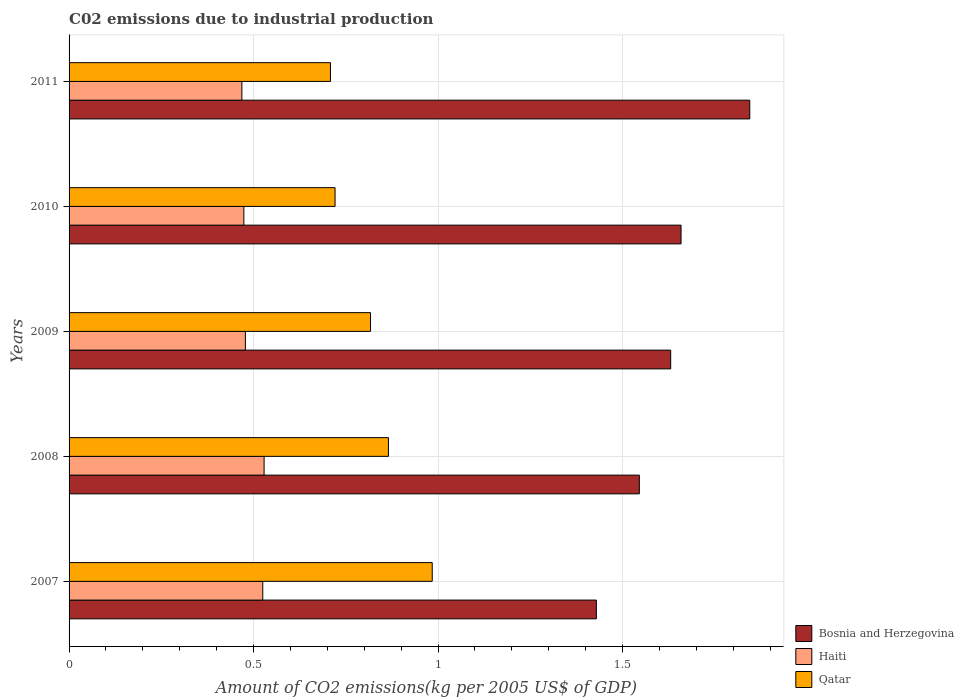How many bars are there on the 1st tick from the top?
Provide a short and direct response. 3. What is the label of the 4th group of bars from the top?
Your answer should be compact. 2008. What is the amount of CO2 emitted due to industrial production in Bosnia and Herzegovina in 2008?
Ensure brevity in your answer.  1.55. Across all years, what is the maximum amount of CO2 emitted due to industrial production in Qatar?
Give a very brief answer. 0.98. Across all years, what is the minimum amount of CO2 emitted due to industrial production in Qatar?
Give a very brief answer. 0.71. What is the total amount of CO2 emitted due to industrial production in Haiti in the graph?
Your answer should be compact. 2.47. What is the difference between the amount of CO2 emitted due to industrial production in Qatar in 2009 and that in 2011?
Make the answer very short. 0.11. What is the difference between the amount of CO2 emitted due to industrial production in Bosnia and Herzegovina in 2010 and the amount of CO2 emitted due to industrial production in Haiti in 2011?
Your response must be concise. 1.19. What is the average amount of CO2 emitted due to industrial production in Haiti per year?
Ensure brevity in your answer.  0.49. In the year 2007, what is the difference between the amount of CO2 emitted due to industrial production in Qatar and amount of CO2 emitted due to industrial production in Haiti?
Your answer should be compact. 0.46. In how many years, is the amount of CO2 emitted due to industrial production in Bosnia and Herzegovina greater than 1.6 kg?
Ensure brevity in your answer.  3. What is the ratio of the amount of CO2 emitted due to industrial production in Haiti in 2008 to that in 2010?
Make the answer very short. 1.12. Is the difference between the amount of CO2 emitted due to industrial production in Qatar in 2008 and 2011 greater than the difference between the amount of CO2 emitted due to industrial production in Haiti in 2008 and 2011?
Your response must be concise. Yes. What is the difference between the highest and the second highest amount of CO2 emitted due to industrial production in Haiti?
Offer a terse response. 0. What is the difference between the highest and the lowest amount of CO2 emitted due to industrial production in Haiti?
Provide a succinct answer. 0.06. Is the sum of the amount of CO2 emitted due to industrial production in Bosnia and Herzegovina in 2009 and 2011 greater than the maximum amount of CO2 emitted due to industrial production in Qatar across all years?
Make the answer very short. Yes. What does the 3rd bar from the top in 2010 represents?
Offer a terse response. Bosnia and Herzegovina. What does the 1st bar from the bottom in 2010 represents?
Your answer should be very brief. Bosnia and Herzegovina. Is it the case that in every year, the sum of the amount of CO2 emitted due to industrial production in Haiti and amount of CO2 emitted due to industrial production in Bosnia and Herzegovina is greater than the amount of CO2 emitted due to industrial production in Qatar?
Offer a terse response. Yes. How many years are there in the graph?
Your response must be concise. 5. Are the values on the major ticks of X-axis written in scientific E-notation?
Your response must be concise. No. Does the graph contain any zero values?
Make the answer very short. No. Does the graph contain grids?
Your answer should be compact. Yes. How many legend labels are there?
Offer a terse response. 3. How are the legend labels stacked?
Provide a succinct answer. Vertical. What is the title of the graph?
Offer a terse response. C02 emissions due to industrial production. Does "Caribbean small states" appear as one of the legend labels in the graph?
Make the answer very short. No. What is the label or title of the X-axis?
Keep it short and to the point. Amount of CO2 emissions(kg per 2005 US$ of GDP). What is the label or title of the Y-axis?
Provide a succinct answer. Years. What is the Amount of CO2 emissions(kg per 2005 US$ of GDP) in Bosnia and Herzegovina in 2007?
Keep it short and to the point. 1.43. What is the Amount of CO2 emissions(kg per 2005 US$ of GDP) of Haiti in 2007?
Provide a succinct answer. 0.52. What is the Amount of CO2 emissions(kg per 2005 US$ of GDP) of Qatar in 2007?
Offer a terse response. 0.98. What is the Amount of CO2 emissions(kg per 2005 US$ of GDP) of Bosnia and Herzegovina in 2008?
Ensure brevity in your answer.  1.55. What is the Amount of CO2 emissions(kg per 2005 US$ of GDP) in Haiti in 2008?
Your answer should be very brief. 0.53. What is the Amount of CO2 emissions(kg per 2005 US$ of GDP) in Qatar in 2008?
Keep it short and to the point. 0.87. What is the Amount of CO2 emissions(kg per 2005 US$ of GDP) of Bosnia and Herzegovina in 2009?
Make the answer very short. 1.63. What is the Amount of CO2 emissions(kg per 2005 US$ of GDP) in Haiti in 2009?
Provide a succinct answer. 0.48. What is the Amount of CO2 emissions(kg per 2005 US$ of GDP) in Qatar in 2009?
Make the answer very short. 0.82. What is the Amount of CO2 emissions(kg per 2005 US$ of GDP) in Bosnia and Herzegovina in 2010?
Keep it short and to the point. 1.66. What is the Amount of CO2 emissions(kg per 2005 US$ of GDP) of Haiti in 2010?
Offer a very short reply. 0.47. What is the Amount of CO2 emissions(kg per 2005 US$ of GDP) of Qatar in 2010?
Keep it short and to the point. 0.72. What is the Amount of CO2 emissions(kg per 2005 US$ of GDP) in Bosnia and Herzegovina in 2011?
Your answer should be very brief. 1.84. What is the Amount of CO2 emissions(kg per 2005 US$ of GDP) in Haiti in 2011?
Make the answer very short. 0.47. What is the Amount of CO2 emissions(kg per 2005 US$ of GDP) of Qatar in 2011?
Ensure brevity in your answer.  0.71. Across all years, what is the maximum Amount of CO2 emissions(kg per 2005 US$ of GDP) in Bosnia and Herzegovina?
Your response must be concise. 1.84. Across all years, what is the maximum Amount of CO2 emissions(kg per 2005 US$ of GDP) of Haiti?
Provide a short and direct response. 0.53. Across all years, what is the maximum Amount of CO2 emissions(kg per 2005 US$ of GDP) in Qatar?
Your answer should be very brief. 0.98. Across all years, what is the minimum Amount of CO2 emissions(kg per 2005 US$ of GDP) of Bosnia and Herzegovina?
Provide a short and direct response. 1.43. Across all years, what is the minimum Amount of CO2 emissions(kg per 2005 US$ of GDP) of Haiti?
Make the answer very short. 0.47. Across all years, what is the minimum Amount of CO2 emissions(kg per 2005 US$ of GDP) in Qatar?
Your answer should be compact. 0.71. What is the total Amount of CO2 emissions(kg per 2005 US$ of GDP) in Bosnia and Herzegovina in the graph?
Ensure brevity in your answer.  8.11. What is the total Amount of CO2 emissions(kg per 2005 US$ of GDP) in Haiti in the graph?
Offer a terse response. 2.47. What is the total Amount of CO2 emissions(kg per 2005 US$ of GDP) in Qatar in the graph?
Make the answer very short. 4.1. What is the difference between the Amount of CO2 emissions(kg per 2005 US$ of GDP) in Bosnia and Herzegovina in 2007 and that in 2008?
Offer a terse response. -0.12. What is the difference between the Amount of CO2 emissions(kg per 2005 US$ of GDP) in Haiti in 2007 and that in 2008?
Provide a succinct answer. -0. What is the difference between the Amount of CO2 emissions(kg per 2005 US$ of GDP) of Qatar in 2007 and that in 2008?
Make the answer very short. 0.12. What is the difference between the Amount of CO2 emissions(kg per 2005 US$ of GDP) in Bosnia and Herzegovina in 2007 and that in 2009?
Provide a short and direct response. -0.2. What is the difference between the Amount of CO2 emissions(kg per 2005 US$ of GDP) of Haiti in 2007 and that in 2009?
Keep it short and to the point. 0.05. What is the difference between the Amount of CO2 emissions(kg per 2005 US$ of GDP) of Qatar in 2007 and that in 2009?
Offer a very short reply. 0.17. What is the difference between the Amount of CO2 emissions(kg per 2005 US$ of GDP) of Bosnia and Herzegovina in 2007 and that in 2010?
Offer a very short reply. -0.23. What is the difference between the Amount of CO2 emissions(kg per 2005 US$ of GDP) in Haiti in 2007 and that in 2010?
Provide a short and direct response. 0.05. What is the difference between the Amount of CO2 emissions(kg per 2005 US$ of GDP) in Qatar in 2007 and that in 2010?
Make the answer very short. 0.26. What is the difference between the Amount of CO2 emissions(kg per 2005 US$ of GDP) of Bosnia and Herzegovina in 2007 and that in 2011?
Provide a succinct answer. -0.42. What is the difference between the Amount of CO2 emissions(kg per 2005 US$ of GDP) in Haiti in 2007 and that in 2011?
Give a very brief answer. 0.06. What is the difference between the Amount of CO2 emissions(kg per 2005 US$ of GDP) of Qatar in 2007 and that in 2011?
Offer a terse response. 0.28. What is the difference between the Amount of CO2 emissions(kg per 2005 US$ of GDP) in Bosnia and Herzegovina in 2008 and that in 2009?
Offer a very short reply. -0.09. What is the difference between the Amount of CO2 emissions(kg per 2005 US$ of GDP) in Haiti in 2008 and that in 2009?
Your answer should be very brief. 0.05. What is the difference between the Amount of CO2 emissions(kg per 2005 US$ of GDP) in Qatar in 2008 and that in 2009?
Offer a terse response. 0.05. What is the difference between the Amount of CO2 emissions(kg per 2005 US$ of GDP) in Bosnia and Herzegovina in 2008 and that in 2010?
Offer a very short reply. -0.11. What is the difference between the Amount of CO2 emissions(kg per 2005 US$ of GDP) of Haiti in 2008 and that in 2010?
Offer a very short reply. 0.05. What is the difference between the Amount of CO2 emissions(kg per 2005 US$ of GDP) of Qatar in 2008 and that in 2010?
Provide a succinct answer. 0.14. What is the difference between the Amount of CO2 emissions(kg per 2005 US$ of GDP) of Bosnia and Herzegovina in 2008 and that in 2011?
Make the answer very short. -0.3. What is the difference between the Amount of CO2 emissions(kg per 2005 US$ of GDP) of Haiti in 2008 and that in 2011?
Give a very brief answer. 0.06. What is the difference between the Amount of CO2 emissions(kg per 2005 US$ of GDP) in Qatar in 2008 and that in 2011?
Provide a succinct answer. 0.16. What is the difference between the Amount of CO2 emissions(kg per 2005 US$ of GDP) of Bosnia and Herzegovina in 2009 and that in 2010?
Keep it short and to the point. -0.03. What is the difference between the Amount of CO2 emissions(kg per 2005 US$ of GDP) of Haiti in 2009 and that in 2010?
Your answer should be very brief. 0. What is the difference between the Amount of CO2 emissions(kg per 2005 US$ of GDP) in Qatar in 2009 and that in 2010?
Keep it short and to the point. 0.1. What is the difference between the Amount of CO2 emissions(kg per 2005 US$ of GDP) of Bosnia and Herzegovina in 2009 and that in 2011?
Make the answer very short. -0.21. What is the difference between the Amount of CO2 emissions(kg per 2005 US$ of GDP) in Haiti in 2009 and that in 2011?
Keep it short and to the point. 0.01. What is the difference between the Amount of CO2 emissions(kg per 2005 US$ of GDP) of Qatar in 2009 and that in 2011?
Make the answer very short. 0.11. What is the difference between the Amount of CO2 emissions(kg per 2005 US$ of GDP) in Bosnia and Herzegovina in 2010 and that in 2011?
Ensure brevity in your answer.  -0.19. What is the difference between the Amount of CO2 emissions(kg per 2005 US$ of GDP) of Haiti in 2010 and that in 2011?
Provide a short and direct response. 0.01. What is the difference between the Amount of CO2 emissions(kg per 2005 US$ of GDP) in Qatar in 2010 and that in 2011?
Offer a terse response. 0.01. What is the difference between the Amount of CO2 emissions(kg per 2005 US$ of GDP) of Bosnia and Herzegovina in 2007 and the Amount of CO2 emissions(kg per 2005 US$ of GDP) of Haiti in 2008?
Provide a succinct answer. 0.9. What is the difference between the Amount of CO2 emissions(kg per 2005 US$ of GDP) of Bosnia and Herzegovina in 2007 and the Amount of CO2 emissions(kg per 2005 US$ of GDP) of Qatar in 2008?
Your answer should be very brief. 0.56. What is the difference between the Amount of CO2 emissions(kg per 2005 US$ of GDP) in Haiti in 2007 and the Amount of CO2 emissions(kg per 2005 US$ of GDP) in Qatar in 2008?
Provide a succinct answer. -0.34. What is the difference between the Amount of CO2 emissions(kg per 2005 US$ of GDP) of Bosnia and Herzegovina in 2007 and the Amount of CO2 emissions(kg per 2005 US$ of GDP) of Haiti in 2009?
Make the answer very short. 0.95. What is the difference between the Amount of CO2 emissions(kg per 2005 US$ of GDP) of Bosnia and Herzegovina in 2007 and the Amount of CO2 emissions(kg per 2005 US$ of GDP) of Qatar in 2009?
Ensure brevity in your answer.  0.61. What is the difference between the Amount of CO2 emissions(kg per 2005 US$ of GDP) in Haiti in 2007 and the Amount of CO2 emissions(kg per 2005 US$ of GDP) in Qatar in 2009?
Keep it short and to the point. -0.29. What is the difference between the Amount of CO2 emissions(kg per 2005 US$ of GDP) in Bosnia and Herzegovina in 2007 and the Amount of CO2 emissions(kg per 2005 US$ of GDP) in Haiti in 2010?
Your response must be concise. 0.96. What is the difference between the Amount of CO2 emissions(kg per 2005 US$ of GDP) of Bosnia and Herzegovina in 2007 and the Amount of CO2 emissions(kg per 2005 US$ of GDP) of Qatar in 2010?
Give a very brief answer. 0.71. What is the difference between the Amount of CO2 emissions(kg per 2005 US$ of GDP) of Haiti in 2007 and the Amount of CO2 emissions(kg per 2005 US$ of GDP) of Qatar in 2010?
Provide a short and direct response. -0.2. What is the difference between the Amount of CO2 emissions(kg per 2005 US$ of GDP) of Bosnia and Herzegovina in 2007 and the Amount of CO2 emissions(kg per 2005 US$ of GDP) of Haiti in 2011?
Provide a succinct answer. 0.96. What is the difference between the Amount of CO2 emissions(kg per 2005 US$ of GDP) of Bosnia and Herzegovina in 2007 and the Amount of CO2 emissions(kg per 2005 US$ of GDP) of Qatar in 2011?
Keep it short and to the point. 0.72. What is the difference between the Amount of CO2 emissions(kg per 2005 US$ of GDP) in Haiti in 2007 and the Amount of CO2 emissions(kg per 2005 US$ of GDP) in Qatar in 2011?
Make the answer very short. -0.18. What is the difference between the Amount of CO2 emissions(kg per 2005 US$ of GDP) of Bosnia and Herzegovina in 2008 and the Amount of CO2 emissions(kg per 2005 US$ of GDP) of Haiti in 2009?
Offer a terse response. 1.07. What is the difference between the Amount of CO2 emissions(kg per 2005 US$ of GDP) of Bosnia and Herzegovina in 2008 and the Amount of CO2 emissions(kg per 2005 US$ of GDP) of Qatar in 2009?
Make the answer very short. 0.73. What is the difference between the Amount of CO2 emissions(kg per 2005 US$ of GDP) in Haiti in 2008 and the Amount of CO2 emissions(kg per 2005 US$ of GDP) in Qatar in 2009?
Ensure brevity in your answer.  -0.29. What is the difference between the Amount of CO2 emissions(kg per 2005 US$ of GDP) of Bosnia and Herzegovina in 2008 and the Amount of CO2 emissions(kg per 2005 US$ of GDP) of Haiti in 2010?
Your answer should be very brief. 1.07. What is the difference between the Amount of CO2 emissions(kg per 2005 US$ of GDP) in Bosnia and Herzegovina in 2008 and the Amount of CO2 emissions(kg per 2005 US$ of GDP) in Qatar in 2010?
Provide a short and direct response. 0.82. What is the difference between the Amount of CO2 emissions(kg per 2005 US$ of GDP) in Haiti in 2008 and the Amount of CO2 emissions(kg per 2005 US$ of GDP) in Qatar in 2010?
Provide a succinct answer. -0.19. What is the difference between the Amount of CO2 emissions(kg per 2005 US$ of GDP) in Bosnia and Herzegovina in 2008 and the Amount of CO2 emissions(kg per 2005 US$ of GDP) in Haiti in 2011?
Your answer should be compact. 1.08. What is the difference between the Amount of CO2 emissions(kg per 2005 US$ of GDP) of Bosnia and Herzegovina in 2008 and the Amount of CO2 emissions(kg per 2005 US$ of GDP) of Qatar in 2011?
Give a very brief answer. 0.84. What is the difference between the Amount of CO2 emissions(kg per 2005 US$ of GDP) in Haiti in 2008 and the Amount of CO2 emissions(kg per 2005 US$ of GDP) in Qatar in 2011?
Offer a terse response. -0.18. What is the difference between the Amount of CO2 emissions(kg per 2005 US$ of GDP) of Bosnia and Herzegovina in 2009 and the Amount of CO2 emissions(kg per 2005 US$ of GDP) of Haiti in 2010?
Offer a terse response. 1.16. What is the difference between the Amount of CO2 emissions(kg per 2005 US$ of GDP) of Bosnia and Herzegovina in 2009 and the Amount of CO2 emissions(kg per 2005 US$ of GDP) of Qatar in 2010?
Your response must be concise. 0.91. What is the difference between the Amount of CO2 emissions(kg per 2005 US$ of GDP) of Haiti in 2009 and the Amount of CO2 emissions(kg per 2005 US$ of GDP) of Qatar in 2010?
Provide a short and direct response. -0.24. What is the difference between the Amount of CO2 emissions(kg per 2005 US$ of GDP) in Bosnia and Herzegovina in 2009 and the Amount of CO2 emissions(kg per 2005 US$ of GDP) in Haiti in 2011?
Make the answer very short. 1.16. What is the difference between the Amount of CO2 emissions(kg per 2005 US$ of GDP) in Bosnia and Herzegovina in 2009 and the Amount of CO2 emissions(kg per 2005 US$ of GDP) in Qatar in 2011?
Provide a short and direct response. 0.92. What is the difference between the Amount of CO2 emissions(kg per 2005 US$ of GDP) in Haiti in 2009 and the Amount of CO2 emissions(kg per 2005 US$ of GDP) in Qatar in 2011?
Offer a terse response. -0.23. What is the difference between the Amount of CO2 emissions(kg per 2005 US$ of GDP) in Bosnia and Herzegovina in 2010 and the Amount of CO2 emissions(kg per 2005 US$ of GDP) in Haiti in 2011?
Your response must be concise. 1.19. What is the difference between the Amount of CO2 emissions(kg per 2005 US$ of GDP) of Bosnia and Herzegovina in 2010 and the Amount of CO2 emissions(kg per 2005 US$ of GDP) of Qatar in 2011?
Offer a terse response. 0.95. What is the difference between the Amount of CO2 emissions(kg per 2005 US$ of GDP) in Haiti in 2010 and the Amount of CO2 emissions(kg per 2005 US$ of GDP) in Qatar in 2011?
Your answer should be very brief. -0.23. What is the average Amount of CO2 emissions(kg per 2005 US$ of GDP) of Bosnia and Herzegovina per year?
Make the answer very short. 1.62. What is the average Amount of CO2 emissions(kg per 2005 US$ of GDP) in Haiti per year?
Give a very brief answer. 0.49. What is the average Amount of CO2 emissions(kg per 2005 US$ of GDP) of Qatar per year?
Your answer should be compact. 0.82. In the year 2007, what is the difference between the Amount of CO2 emissions(kg per 2005 US$ of GDP) in Bosnia and Herzegovina and Amount of CO2 emissions(kg per 2005 US$ of GDP) in Haiti?
Give a very brief answer. 0.9. In the year 2007, what is the difference between the Amount of CO2 emissions(kg per 2005 US$ of GDP) in Bosnia and Herzegovina and Amount of CO2 emissions(kg per 2005 US$ of GDP) in Qatar?
Your response must be concise. 0.44. In the year 2007, what is the difference between the Amount of CO2 emissions(kg per 2005 US$ of GDP) of Haiti and Amount of CO2 emissions(kg per 2005 US$ of GDP) of Qatar?
Provide a short and direct response. -0.46. In the year 2008, what is the difference between the Amount of CO2 emissions(kg per 2005 US$ of GDP) of Bosnia and Herzegovina and Amount of CO2 emissions(kg per 2005 US$ of GDP) of Haiti?
Your answer should be very brief. 1.02. In the year 2008, what is the difference between the Amount of CO2 emissions(kg per 2005 US$ of GDP) of Bosnia and Herzegovina and Amount of CO2 emissions(kg per 2005 US$ of GDP) of Qatar?
Your response must be concise. 0.68. In the year 2008, what is the difference between the Amount of CO2 emissions(kg per 2005 US$ of GDP) in Haiti and Amount of CO2 emissions(kg per 2005 US$ of GDP) in Qatar?
Offer a terse response. -0.34. In the year 2009, what is the difference between the Amount of CO2 emissions(kg per 2005 US$ of GDP) in Bosnia and Herzegovina and Amount of CO2 emissions(kg per 2005 US$ of GDP) in Haiti?
Your response must be concise. 1.15. In the year 2009, what is the difference between the Amount of CO2 emissions(kg per 2005 US$ of GDP) of Bosnia and Herzegovina and Amount of CO2 emissions(kg per 2005 US$ of GDP) of Qatar?
Your answer should be very brief. 0.81. In the year 2009, what is the difference between the Amount of CO2 emissions(kg per 2005 US$ of GDP) of Haiti and Amount of CO2 emissions(kg per 2005 US$ of GDP) of Qatar?
Provide a succinct answer. -0.34. In the year 2010, what is the difference between the Amount of CO2 emissions(kg per 2005 US$ of GDP) in Bosnia and Herzegovina and Amount of CO2 emissions(kg per 2005 US$ of GDP) in Haiti?
Provide a succinct answer. 1.18. In the year 2010, what is the difference between the Amount of CO2 emissions(kg per 2005 US$ of GDP) in Bosnia and Herzegovina and Amount of CO2 emissions(kg per 2005 US$ of GDP) in Qatar?
Make the answer very short. 0.94. In the year 2010, what is the difference between the Amount of CO2 emissions(kg per 2005 US$ of GDP) in Haiti and Amount of CO2 emissions(kg per 2005 US$ of GDP) in Qatar?
Make the answer very short. -0.25. In the year 2011, what is the difference between the Amount of CO2 emissions(kg per 2005 US$ of GDP) in Bosnia and Herzegovina and Amount of CO2 emissions(kg per 2005 US$ of GDP) in Haiti?
Ensure brevity in your answer.  1.38. In the year 2011, what is the difference between the Amount of CO2 emissions(kg per 2005 US$ of GDP) of Bosnia and Herzegovina and Amount of CO2 emissions(kg per 2005 US$ of GDP) of Qatar?
Make the answer very short. 1.14. In the year 2011, what is the difference between the Amount of CO2 emissions(kg per 2005 US$ of GDP) in Haiti and Amount of CO2 emissions(kg per 2005 US$ of GDP) in Qatar?
Give a very brief answer. -0.24. What is the ratio of the Amount of CO2 emissions(kg per 2005 US$ of GDP) in Bosnia and Herzegovina in 2007 to that in 2008?
Ensure brevity in your answer.  0.92. What is the ratio of the Amount of CO2 emissions(kg per 2005 US$ of GDP) in Haiti in 2007 to that in 2008?
Your answer should be compact. 0.99. What is the ratio of the Amount of CO2 emissions(kg per 2005 US$ of GDP) of Qatar in 2007 to that in 2008?
Provide a succinct answer. 1.14. What is the ratio of the Amount of CO2 emissions(kg per 2005 US$ of GDP) in Bosnia and Herzegovina in 2007 to that in 2009?
Offer a very short reply. 0.88. What is the ratio of the Amount of CO2 emissions(kg per 2005 US$ of GDP) in Haiti in 2007 to that in 2009?
Your response must be concise. 1.1. What is the ratio of the Amount of CO2 emissions(kg per 2005 US$ of GDP) in Qatar in 2007 to that in 2009?
Make the answer very short. 1.2. What is the ratio of the Amount of CO2 emissions(kg per 2005 US$ of GDP) of Bosnia and Herzegovina in 2007 to that in 2010?
Your answer should be compact. 0.86. What is the ratio of the Amount of CO2 emissions(kg per 2005 US$ of GDP) of Haiti in 2007 to that in 2010?
Ensure brevity in your answer.  1.11. What is the ratio of the Amount of CO2 emissions(kg per 2005 US$ of GDP) of Qatar in 2007 to that in 2010?
Keep it short and to the point. 1.37. What is the ratio of the Amount of CO2 emissions(kg per 2005 US$ of GDP) in Bosnia and Herzegovina in 2007 to that in 2011?
Your answer should be very brief. 0.77. What is the ratio of the Amount of CO2 emissions(kg per 2005 US$ of GDP) of Haiti in 2007 to that in 2011?
Offer a terse response. 1.12. What is the ratio of the Amount of CO2 emissions(kg per 2005 US$ of GDP) of Qatar in 2007 to that in 2011?
Provide a short and direct response. 1.39. What is the ratio of the Amount of CO2 emissions(kg per 2005 US$ of GDP) in Bosnia and Herzegovina in 2008 to that in 2009?
Provide a succinct answer. 0.95. What is the ratio of the Amount of CO2 emissions(kg per 2005 US$ of GDP) in Haiti in 2008 to that in 2009?
Offer a terse response. 1.11. What is the ratio of the Amount of CO2 emissions(kg per 2005 US$ of GDP) in Qatar in 2008 to that in 2009?
Provide a short and direct response. 1.06. What is the ratio of the Amount of CO2 emissions(kg per 2005 US$ of GDP) in Bosnia and Herzegovina in 2008 to that in 2010?
Your response must be concise. 0.93. What is the ratio of the Amount of CO2 emissions(kg per 2005 US$ of GDP) in Haiti in 2008 to that in 2010?
Your answer should be very brief. 1.12. What is the ratio of the Amount of CO2 emissions(kg per 2005 US$ of GDP) of Qatar in 2008 to that in 2010?
Provide a short and direct response. 1.2. What is the ratio of the Amount of CO2 emissions(kg per 2005 US$ of GDP) of Bosnia and Herzegovina in 2008 to that in 2011?
Ensure brevity in your answer.  0.84. What is the ratio of the Amount of CO2 emissions(kg per 2005 US$ of GDP) of Haiti in 2008 to that in 2011?
Give a very brief answer. 1.13. What is the ratio of the Amount of CO2 emissions(kg per 2005 US$ of GDP) in Qatar in 2008 to that in 2011?
Make the answer very short. 1.22. What is the ratio of the Amount of CO2 emissions(kg per 2005 US$ of GDP) in Bosnia and Herzegovina in 2009 to that in 2010?
Give a very brief answer. 0.98. What is the ratio of the Amount of CO2 emissions(kg per 2005 US$ of GDP) of Haiti in 2009 to that in 2010?
Give a very brief answer. 1.01. What is the ratio of the Amount of CO2 emissions(kg per 2005 US$ of GDP) of Qatar in 2009 to that in 2010?
Provide a succinct answer. 1.13. What is the ratio of the Amount of CO2 emissions(kg per 2005 US$ of GDP) in Bosnia and Herzegovina in 2009 to that in 2011?
Provide a succinct answer. 0.88. What is the ratio of the Amount of CO2 emissions(kg per 2005 US$ of GDP) of Haiti in 2009 to that in 2011?
Keep it short and to the point. 1.02. What is the ratio of the Amount of CO2 emissions(kg per 2005 US$ of GDP) of Qatar in 2009 to that in 2011?
Make the answer very short. 1.15. What is the ratio of the Amount of CO2 emissions(kg per 2005 US$ of GDP) of Bosnia and Herzegovina in 2010 to that in 2011?
Your answer should be very brief. 0.9. What is the ratio of the Amount of CO2 emissions(kg per 2005 US$ of GDP) of Haiti in 2010 to that in 2011?
Make the answer very short. 1.01. What is the ratio of the Amount of CO2 emissions(kg per 2005 US$ of GDP) of Qatar in 2010 to that in 2011?
Your answer should be very brief. 1.02. What is the difference between the highest and the second highest Amount of CO2 emissions(kg per 2005 US$ of GDP) in Bosnia and Herzegovina?
Provide a succinct answer. 0.19. What is the difference between the highest and the second highest Amount of CO2 emissions(kg per 2005 US$ of GDP) in Haiti?
Make the answer very short. 0. What is the difference between the highest and the second highest Amount of CO2 emissions(kg per 2005 US$ of GDP) in Qatar?
Offer a very short reply. 0.12. What is the difference between the highest and the lowest Amount of CO2 emissions(kg per 2005 US$ of GDP) of Bosnia and Herzegovina?
Provide a succinct answer. 0.42. What is the difference between the highest and the lowest Amount of CO2 emissions(kg per 2005 US$ of GDP) in Haiti?
Your response must be concise. 0.06. What is the difference between the highest and the lowest Amount of CO2 emissions(kg per 2005 US$ of GDP) of Qatar?
Ensure brevity in your answer.  0.28. 